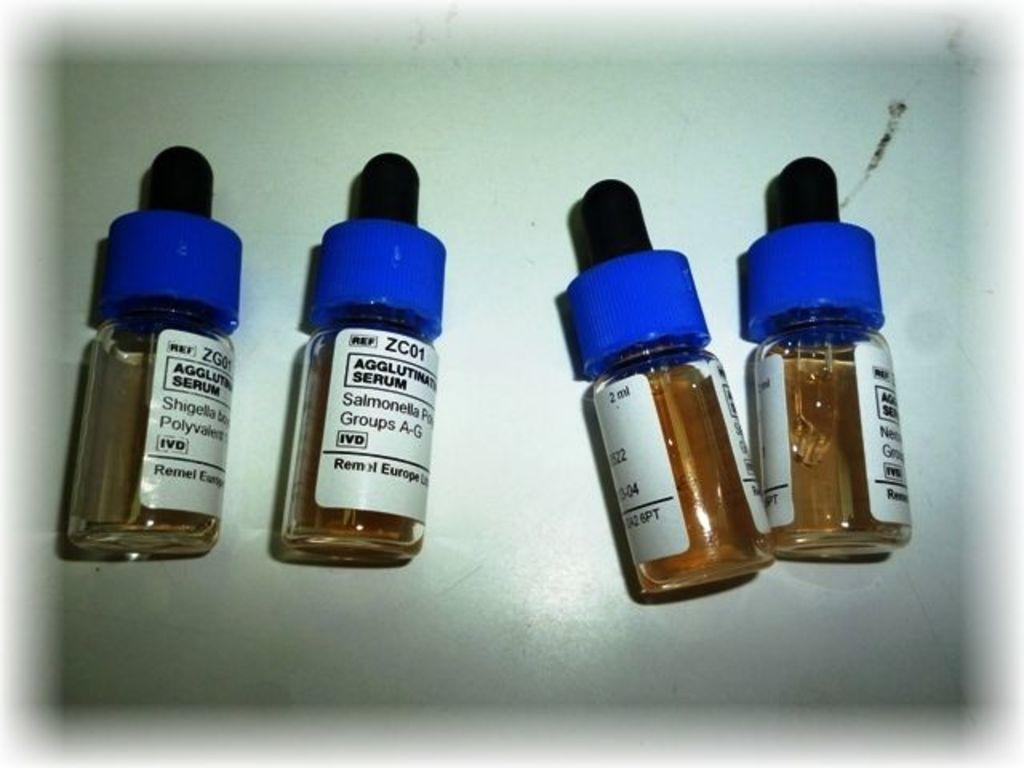How many bottles are visible in the image? There are four bottles in the image. What feature do all the bottles have in common? Each bottle has a dropper on top. Is there a chair next to the bottles in the image? There is no mention of a chair in the provided facts, so we cannot determine if one is present in the image. 